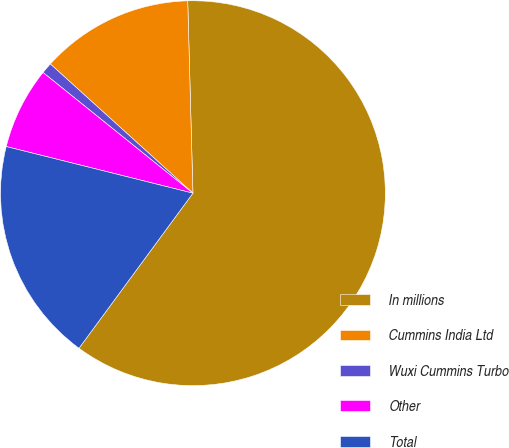<chart> <loc_0><loc_0><loc_500><loc_500><pie_chart><fcel>In millions<fcel>Cummins India Ltd<fcel>Wuxi Cummins Turbo<fcel>Other<fcel>Total<nl><fcel>60.51%<fcel>12.85%<fcel>0.93%<fcel>6.89%<fcel>18.81%<nl></chart> 